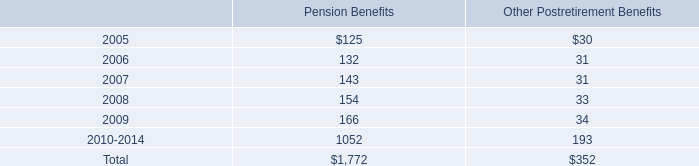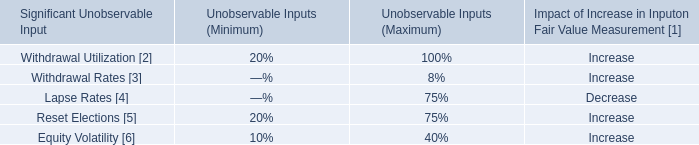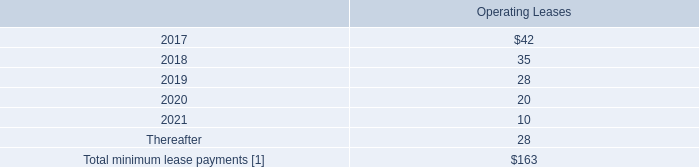what portion of the total expected payment for benefits is related to pension benefits? 
Computations: (1772 / (1772 + 352))
Answer: 0.83427. 